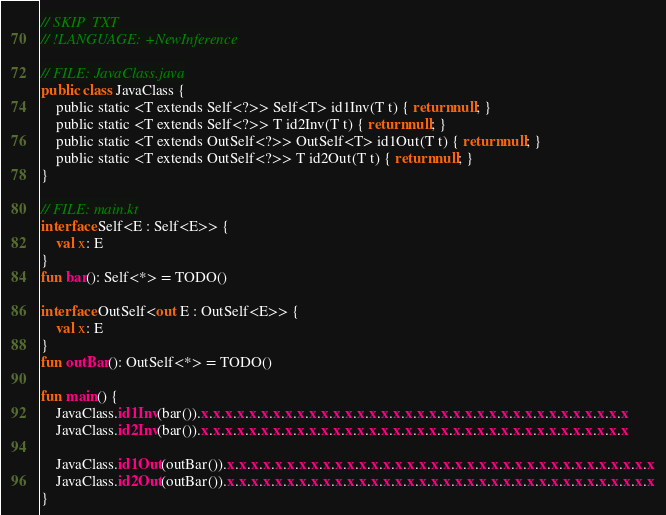<code> <loc_0><loc_0><loc_500><loc_500><_Kotlin_>// SKIP_TXT
// !LANGUAGE: +NewInference

// FILE: JavaClass.java
public class JavaClass {
    public static <T extends Self<?>> Self<T> id1Inv(T t) { return null; }
    public static <T extends Self<?>> T id2Inv(T t) { return null; }
    public static <T extends OutSelf<?>> OutSelf<T> id1Out(T t) { return null; }
    public static <T extends OutSelf<?>> T id2Out(T t) { return null; }
}

// FILE: main.kt
interface Self<E : Self<E>> {
    val x: E
}
fun bar(): Self<*> = TODO()

interface OutSelf<out E : OutSelf<E>> {
    val x: E
}
fun outBar(): OutSelf<*> = TODO()

fun main() {
    JavaClass.id1Inv(bar()).x.x.x.x.x.x.x.x.x.x.x.x.x.x.x.x.x.x.x.x.x.x.x.x.x.x.x.x.x.x.x.x.x.x.x.x
    JavaClass.id2Inv(bar()).x.x.x.x.x.x.x.x.x.x.x.x.x.x.x.x.x.x.x.x.x.x.x.x.x.x.x.x.x.x.x.x.x.x.x.x

    JavaClass.id1Out(outBar()).x.x.x.x.x.x.x.x.x.x.x.x.x.x.x.x.x.x.x.x.x.x.x.x.x.x.x.x.x.x.x.x.x.x.x.x
    JavaClass.id2Out(outBar()).x.x.x.x.x.x.x.x.x.x.x.x.x.x.x.x.x.x.x.x.x.x.x.x.x.x.x.x.x.x.x.x.x.x.x.x
}
</code> 